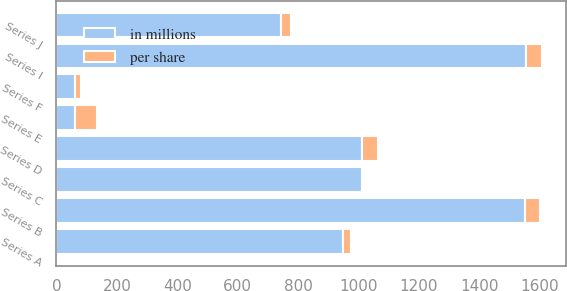Convert chart to OTSL. <chart><loc_0><loc_0><loc_500><loc_500><stacked_bar_chart><ecel><fcel>Series A<fcel>Series B<fcel>Series C<fcel>Series D<fcel>Series E<fcel>Series F<fcel>Series I<fcel>Series J<nl><fcel>in millions<fcel>947.92<fcel>1550<fcel>1011.11<fcel>1011.11<fcel>62.5<fcel>62.5<fcel>1553.63<fcel>744.79<nl><fcel>per share<fcel>28<fcel>50<fcel>8<fcel>54<fcel>71<fcel>20<fcel>53<fcel>30<nl></chart> 